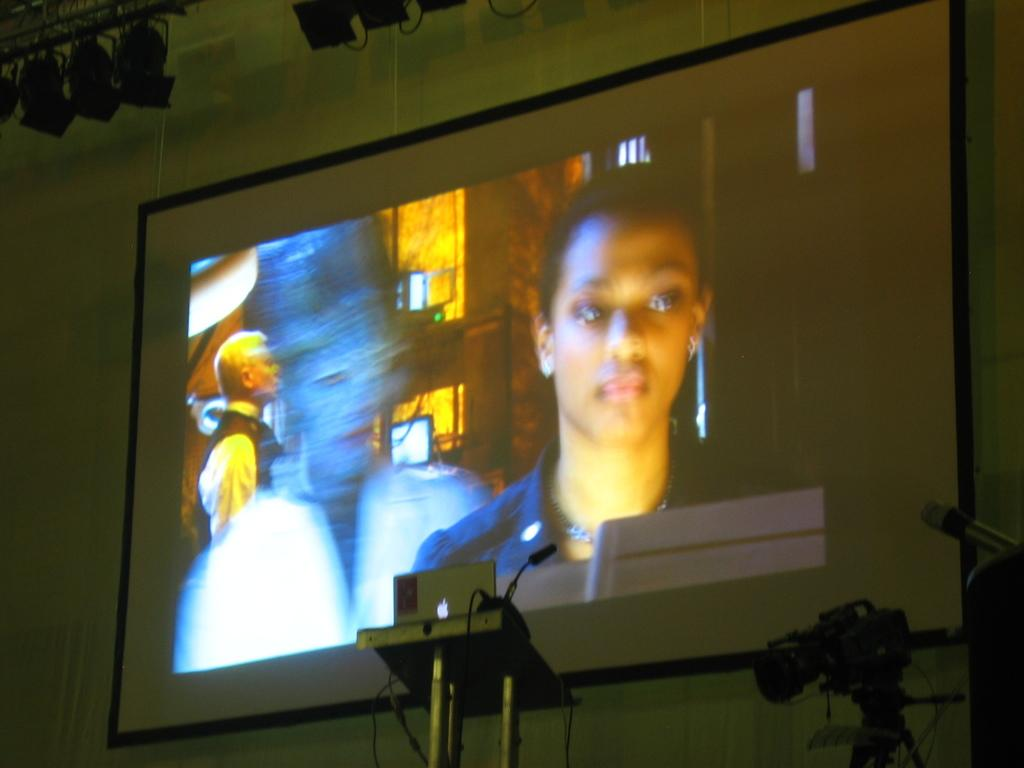What type of laptop is visible in the image? There is a MacBook in the image. What can be seen on the podium in the image? There is a microphone on a podium in the image. What devices are used for capturing images in the image? There are cameras in the image. What are the focus lights used for in the image? The focus lights are used for illuminating specific areas in the image. What structure is present in the image to support lighting equipment? There is a lighting truss in the image. What is displayed on the wall in the image? There is a screen on the wall in the image. How many bats are hanging from the lighting truss in the image? There are no bats present in the image; it features a MacBook, microphone, cameras, focus lights, lighting truss, and a screen on the wall. What type of servant is shown assisting the person with the MacBook in the image? There is no servant present in the image; it only features the mentioned objects and no people. 